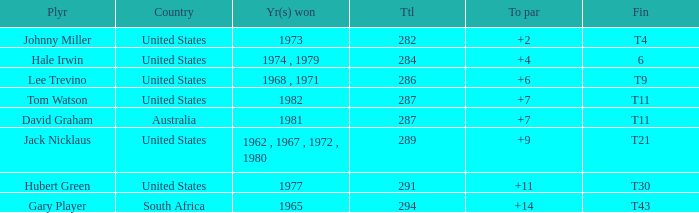WHAT IS THE TOTAL, OF A TO PAR FOR HUBERT GREEN, AND A TOTAL LARGER THAN 291? 0.0. 